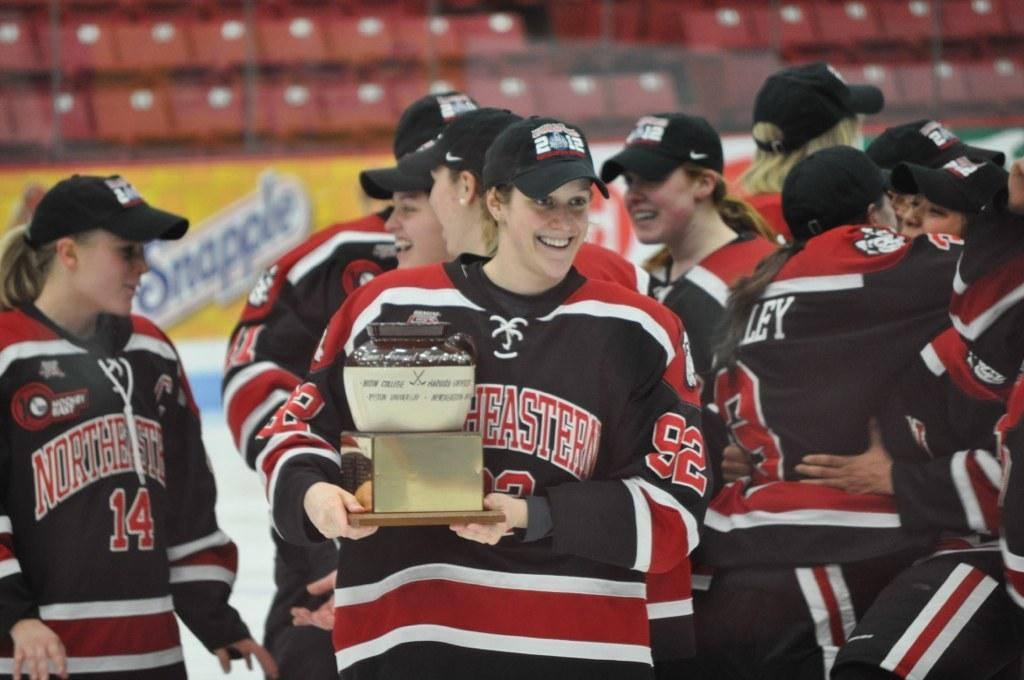<image>
Share a concise interpretation of the image provided. An ice hockey team with Northeastern on their jerseys celebrate on ice, one member holding an award. 